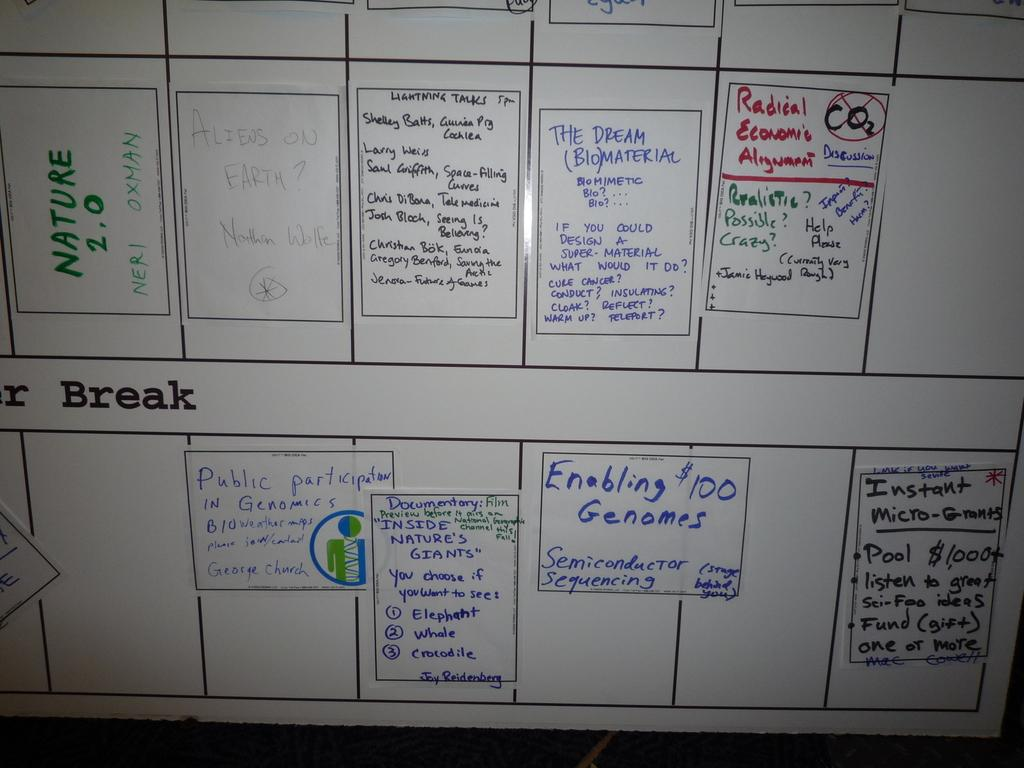<image>
Write a terse but informative summary of the picture. A students whiteboard of various divided notes regarding their class. 